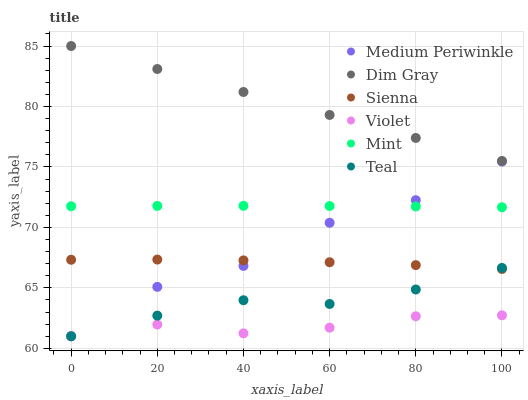Does Violet have the minimum area under the curve?
Answer yes or no. Yes. Does Dim Gray have the maximum area under the curve?
Answer yes or no. Yes. Does Medium Periwinkle have the minimum area under the curve?
Answer yes or no. No. Does Medium Periwinkle have the maximum area under the curve?
Answer yes or no. No. Is Dim Gray the smoothest?
Answer yes or no. Yes. Is Medium Periwinkle the roughest?
Answer yes or no. Yes. Is Sienna the smoothest?
Answer yes or no. No. Is Sienna the roughest?
Answer yes or no. No. Does Medium Periwinkle have the lowest value?
Answer yes or no. Yes. Does Sienna have the lowest value?
Answer yes or no. No. Does Dim Gray have the highest value?
Answer yes or no. Yes. Does Medium Periwinkle have the highest value?
Answer yes or no. No. Is Teal less than Dim Gray?
Answer yes or no. Yes. Is Dim Gray greater than Teal?
Answer yes or no. Yes. Does Medium Periwinkle intersect Teal?
Answer yes or no. Yes. Is Medium Periwinkle less than Teal?
Answer yes or no. No. Is Medium Periwinkle greater than Teal?
Answer yes or no. No. Does Teal intersect Dim Gray?
Answer yes or no. No. 